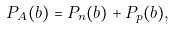<formula> <loc_0><loc_0><loc_500><loc_500>P _ { A } ( b ) = P _ { n } ( b ) + P _ { p } ( b ) ,</formula> 